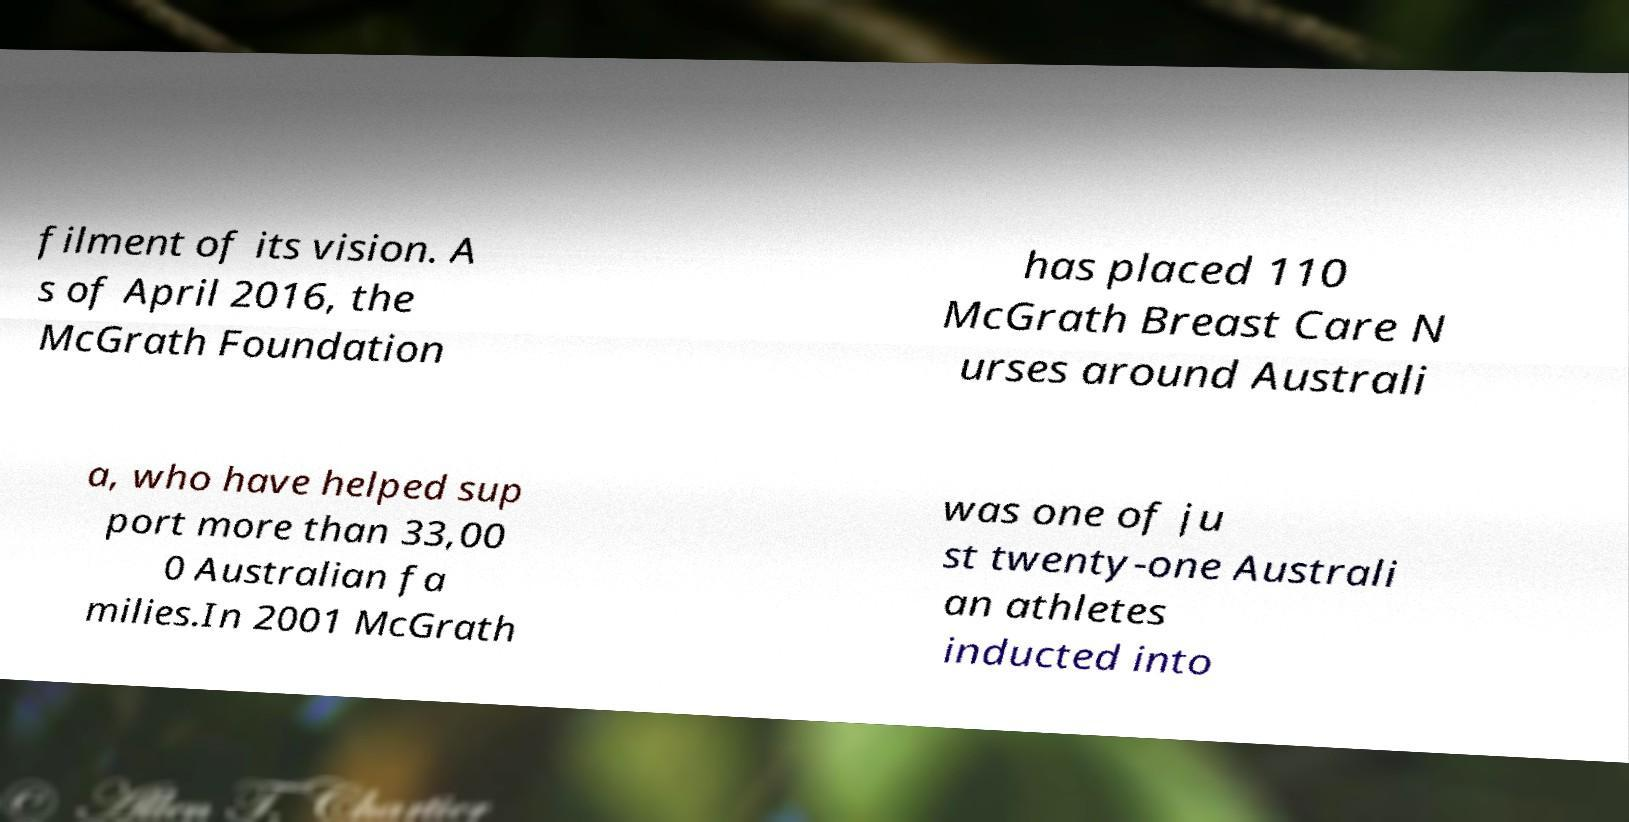Can you read and provide the text displayed in the image?This photo seems to have some interesting text. Can you extract and type it out for me? filment of its vision. A s of April 2016, the McGrath Foundation has placed 110 McGrath Breast Care N urses around Australi a, who have helped sup port more than 33,00 0 Australian fa milies.In 2001 McGrath was one of ju st twenty-one Australi an athletes inducted into 